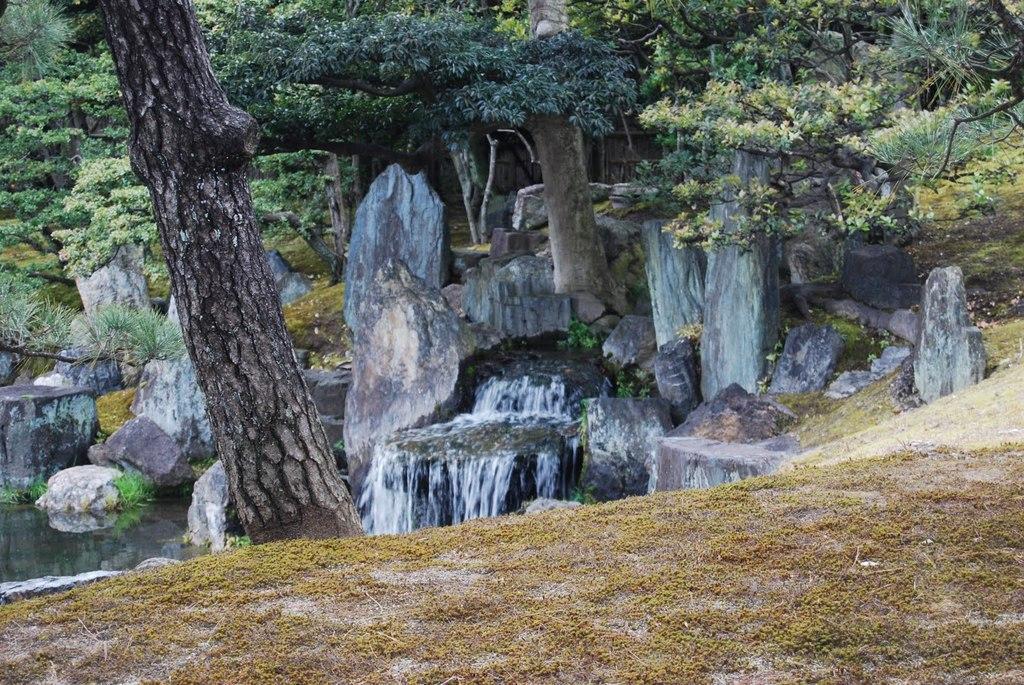How would you summarize this image in a sentence or two? In the foreground of this image, there is grass land and a tree trunk. In the background, there is waterfall, rocks, water and trees. 